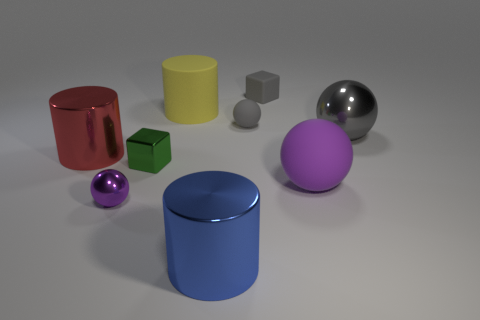Subtract 1 spheres. How many spheres are left? 3 Subtract all big purple balls. How many balls are left? 3 Subtract all green cubes. How many cubes are left? 1 Subtract all gray spheres. Subtract all green cylinders. How many spheres are left? 2 Add 1 tiny gray blocks. How many tiny gray blocks are left? 2 Add 5 small yellow matte balls. How many small yellow matte balls exist? 5 Add 1 green matte blocks. How many objects exist? 10 Subtract 0 purple cubes. How many objects are left? 9 Subtract all spheres. How many objects are left? 5 Subtract all yellow balls. How many yellow cylinders are left? 1 